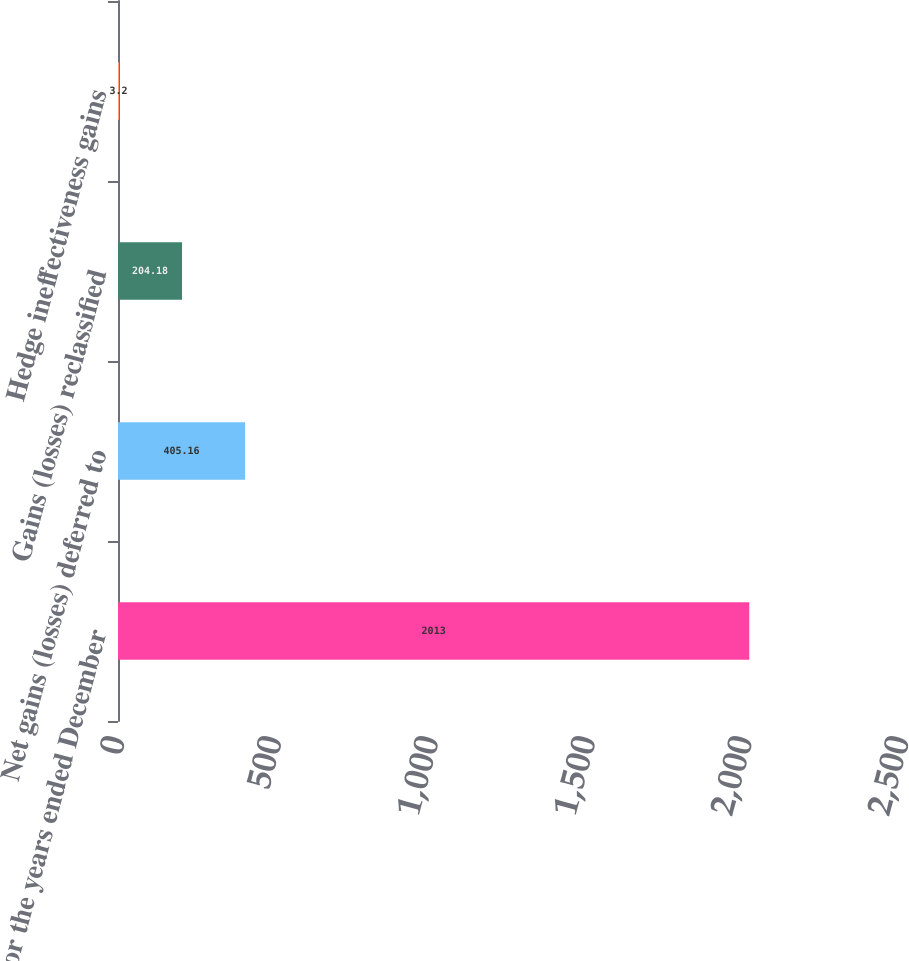Convert chart to OTSL. <chart><loc_0><loc_0><loc_500><loc_500><bar_chart><fcel>For the years ended December<fcel>Net gains (losses) deferred to<fcel>Gains (losses) reclassified<fcel>Hedge ineffectiveness gains<nl><fcel>2013<fcel>405.16<fcel>204.18<fcel>3.2<nl></chart> 